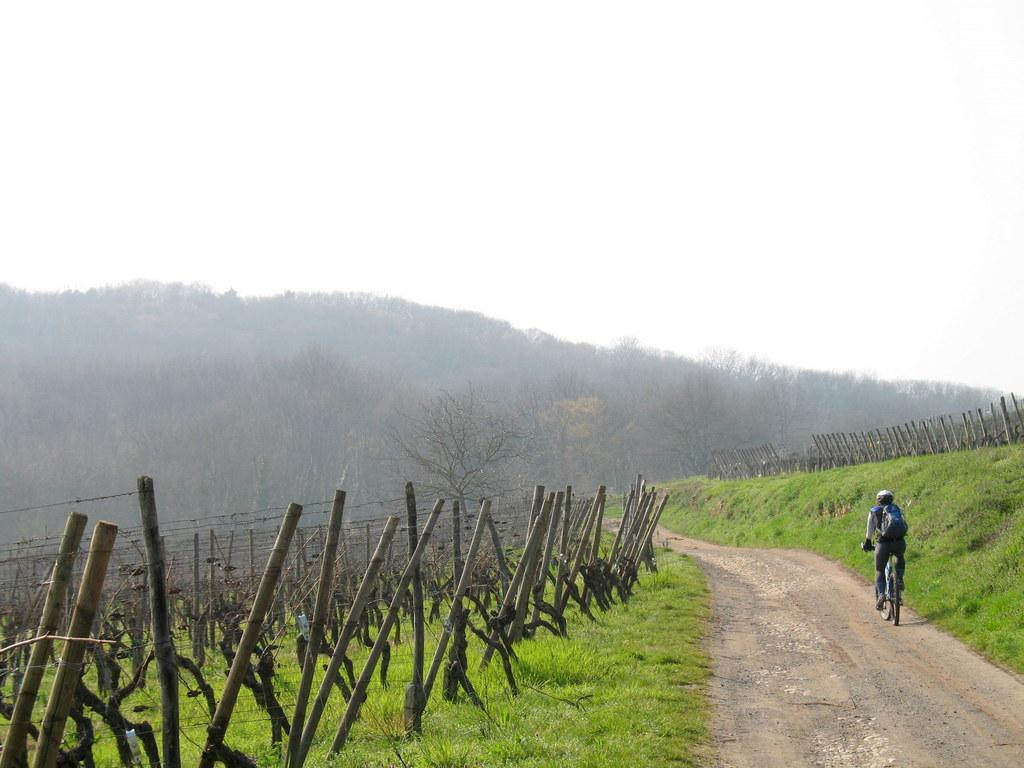What is the person in the image doing? There is a person riding a bicycle on the road in the image. What type of vegetation can be seen in the image? There are trees and grass in the image. Can you describe the grass in the image? The grass appears to be bamboo. What is visible in the background of the image? The sky is visible in the image. What shape is the cactus in the image? There is no cactus present in the image. How many fangs does the person riding the bicycle have in the image? The person riding the bicycle does not have any fangs in the image. 